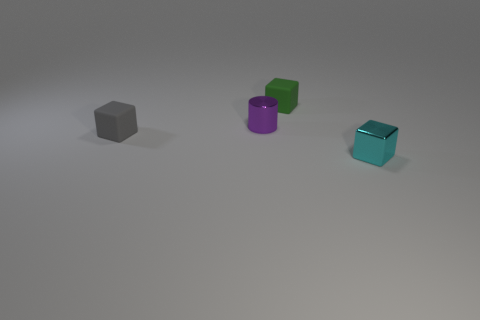What size is the cyan block that is the same material as the tiny purple thing?
Give a very brief answer. Small. How many other small things are the same shape as the tiny purple thing?
Give a very brief answer. 0. How many green rubber things are there?
Make the answer very short. 1. There is a gray matte object that is in front of the green block; does it have the same shape as the small purple metal object?
Offer a very short reply. No. Are there an equal number of blue blocks and cyan shiny cubes?
Your response must be concise. No. There is a green thing that is the same size as the gray block; what material is it?
Your answer should be very brief. Rubber. Is there a large gray block made of the same material as the purple object?
Provide a short and direct response. No. Does the purple thing have the same shape as the tiny metallic object on the right side of the green rubber cube?
Ensure brevity in your answer.  No. How many small things are both behind the tiny metal cylinder and on the left side of the purple shiny cylinder?
Offer a very short reply. 0. Do the small gray object and the tiny object in front of the small gray object have the same material?
Your answer should be very brief. No. 